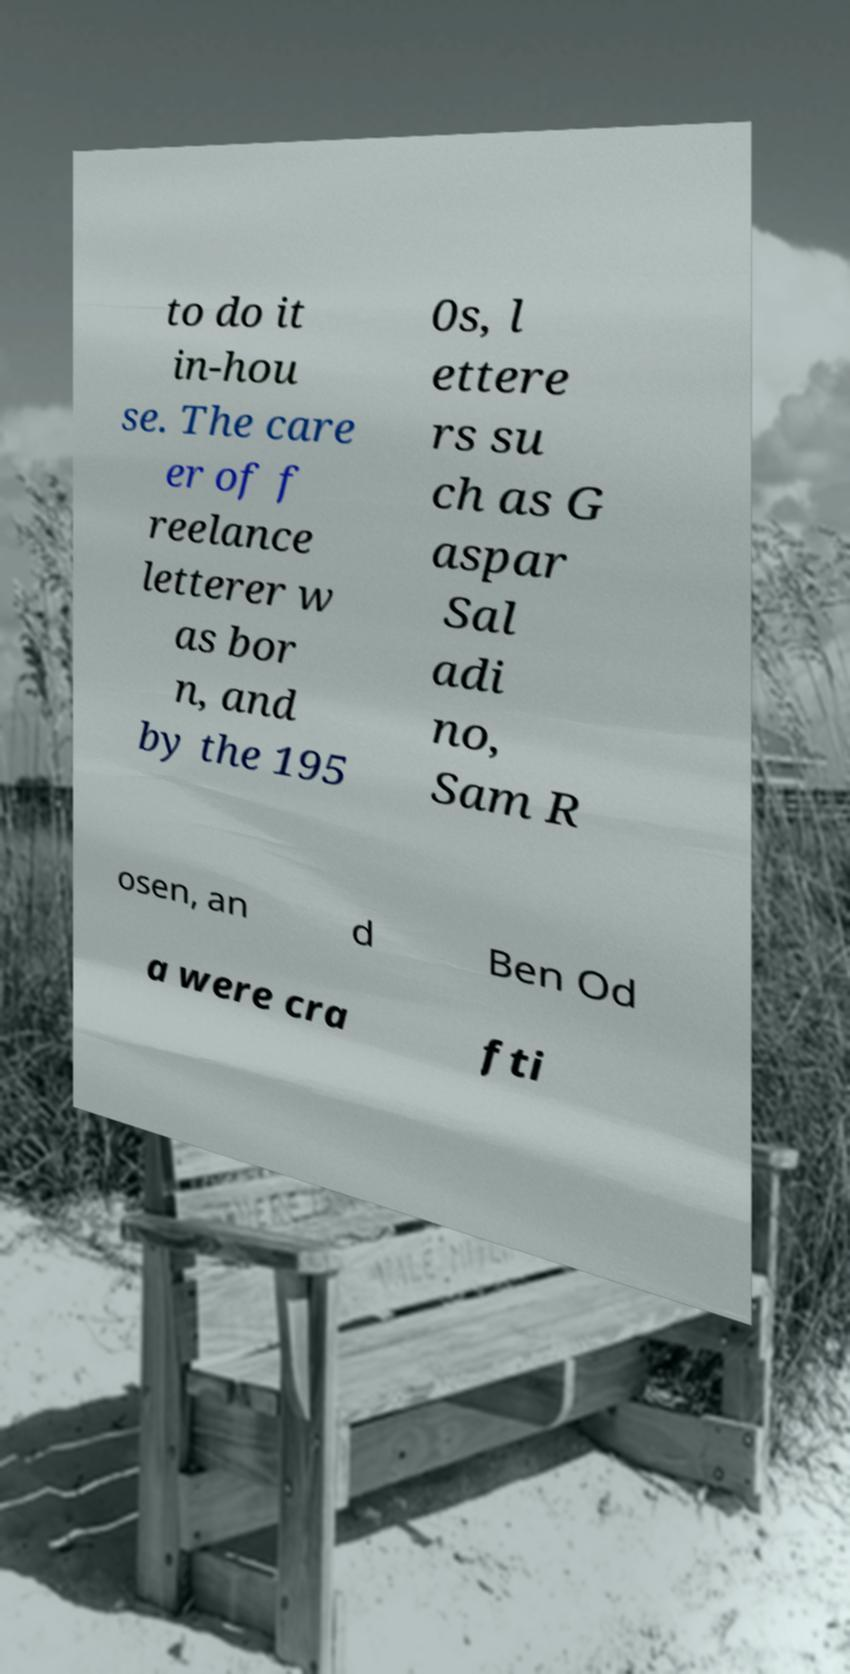Please identify and transcribe the text found in this image. to do it in-hou se. The care er of f reelance letterer w as bor n, and by the 195 0s, l ettere rs su ch as G aspar Sal adi no, Sam R osen, an d Ben Od a were cra fti 